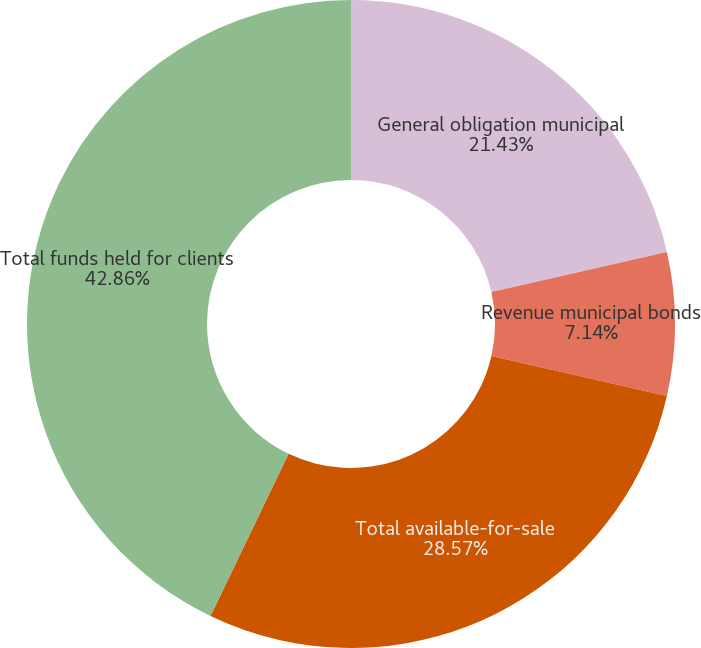Convert chart. <chart><loc_0><loc_0><loc_500><loc_500><pie_chart><fcel>General obligation municipal<fcel>Revenue municipal bonds<fcel>Total available-for-sale<fcel>Total funds held for clients<nl><fcel>21.43%<fcel>7.14%<fcel>28.57%<fcel>42.86%<nl></chart> 